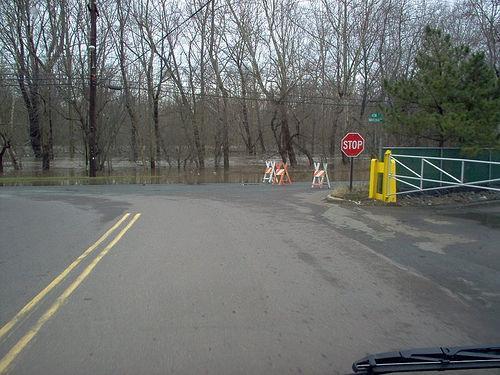How many stop signs are there?
Give a very brief answer. 1. 